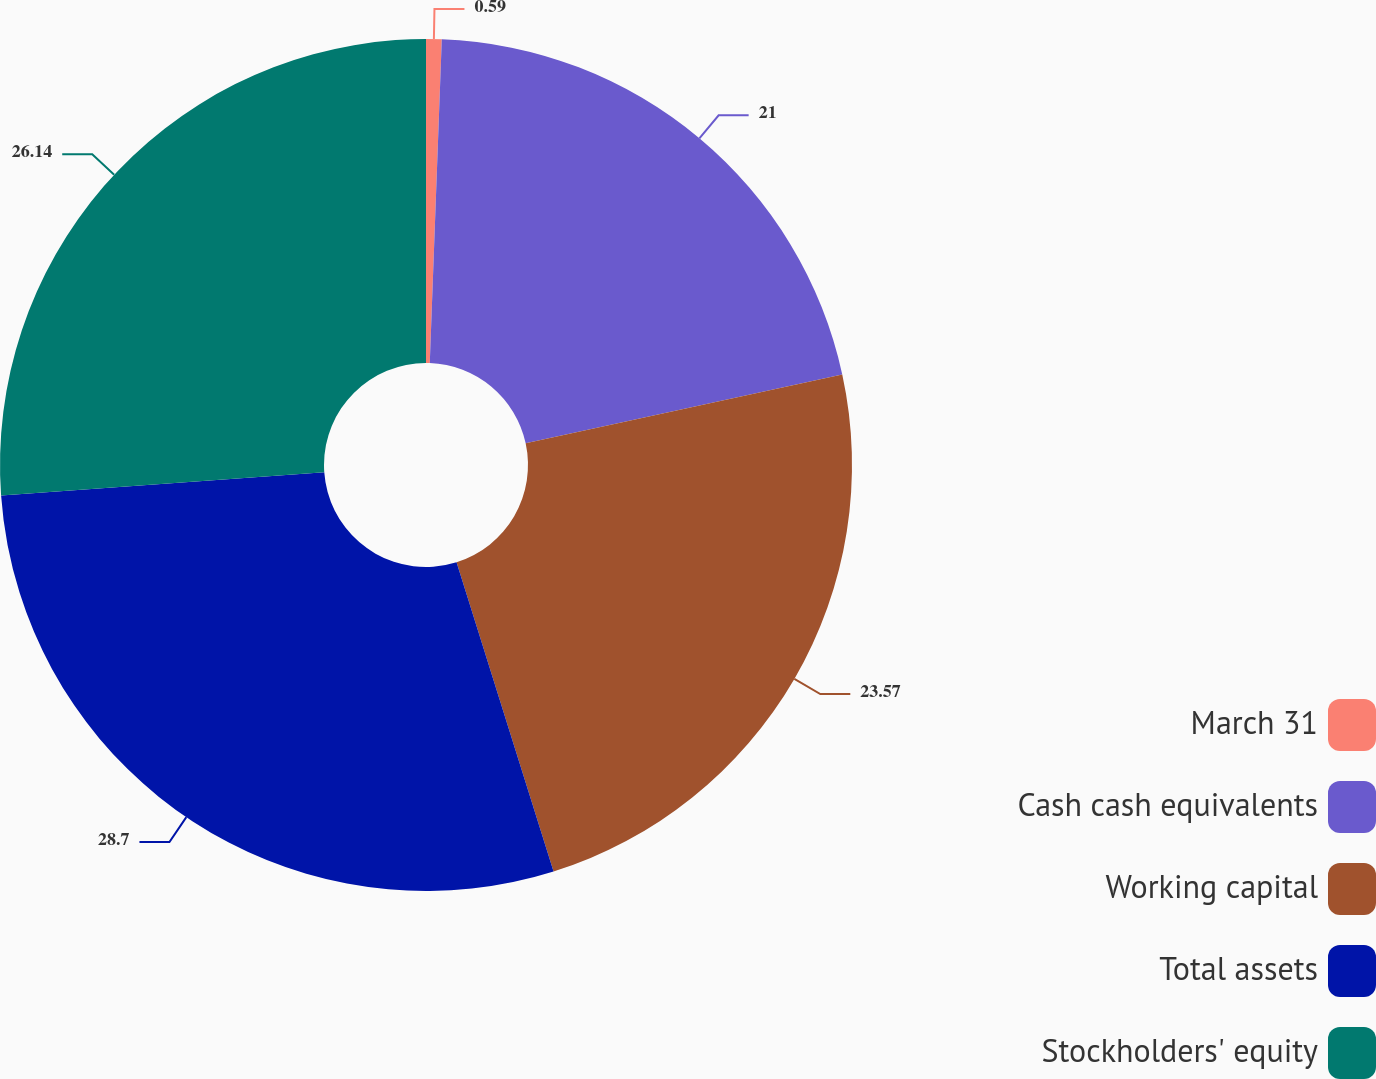Convert chart. <chart><loc_0><loc_0><loc_500><loc_500><pie_chart><fcel>March 31<fcel>Cash cash equivalents<fcel>Working capital<fcel>Total assets<fcel>Stockholders' equity<nl><fcel>0.59%<fcel>21.0%<fcel>23.57%<fcel>28.7%<fcel>26.14%<nl></chart> 